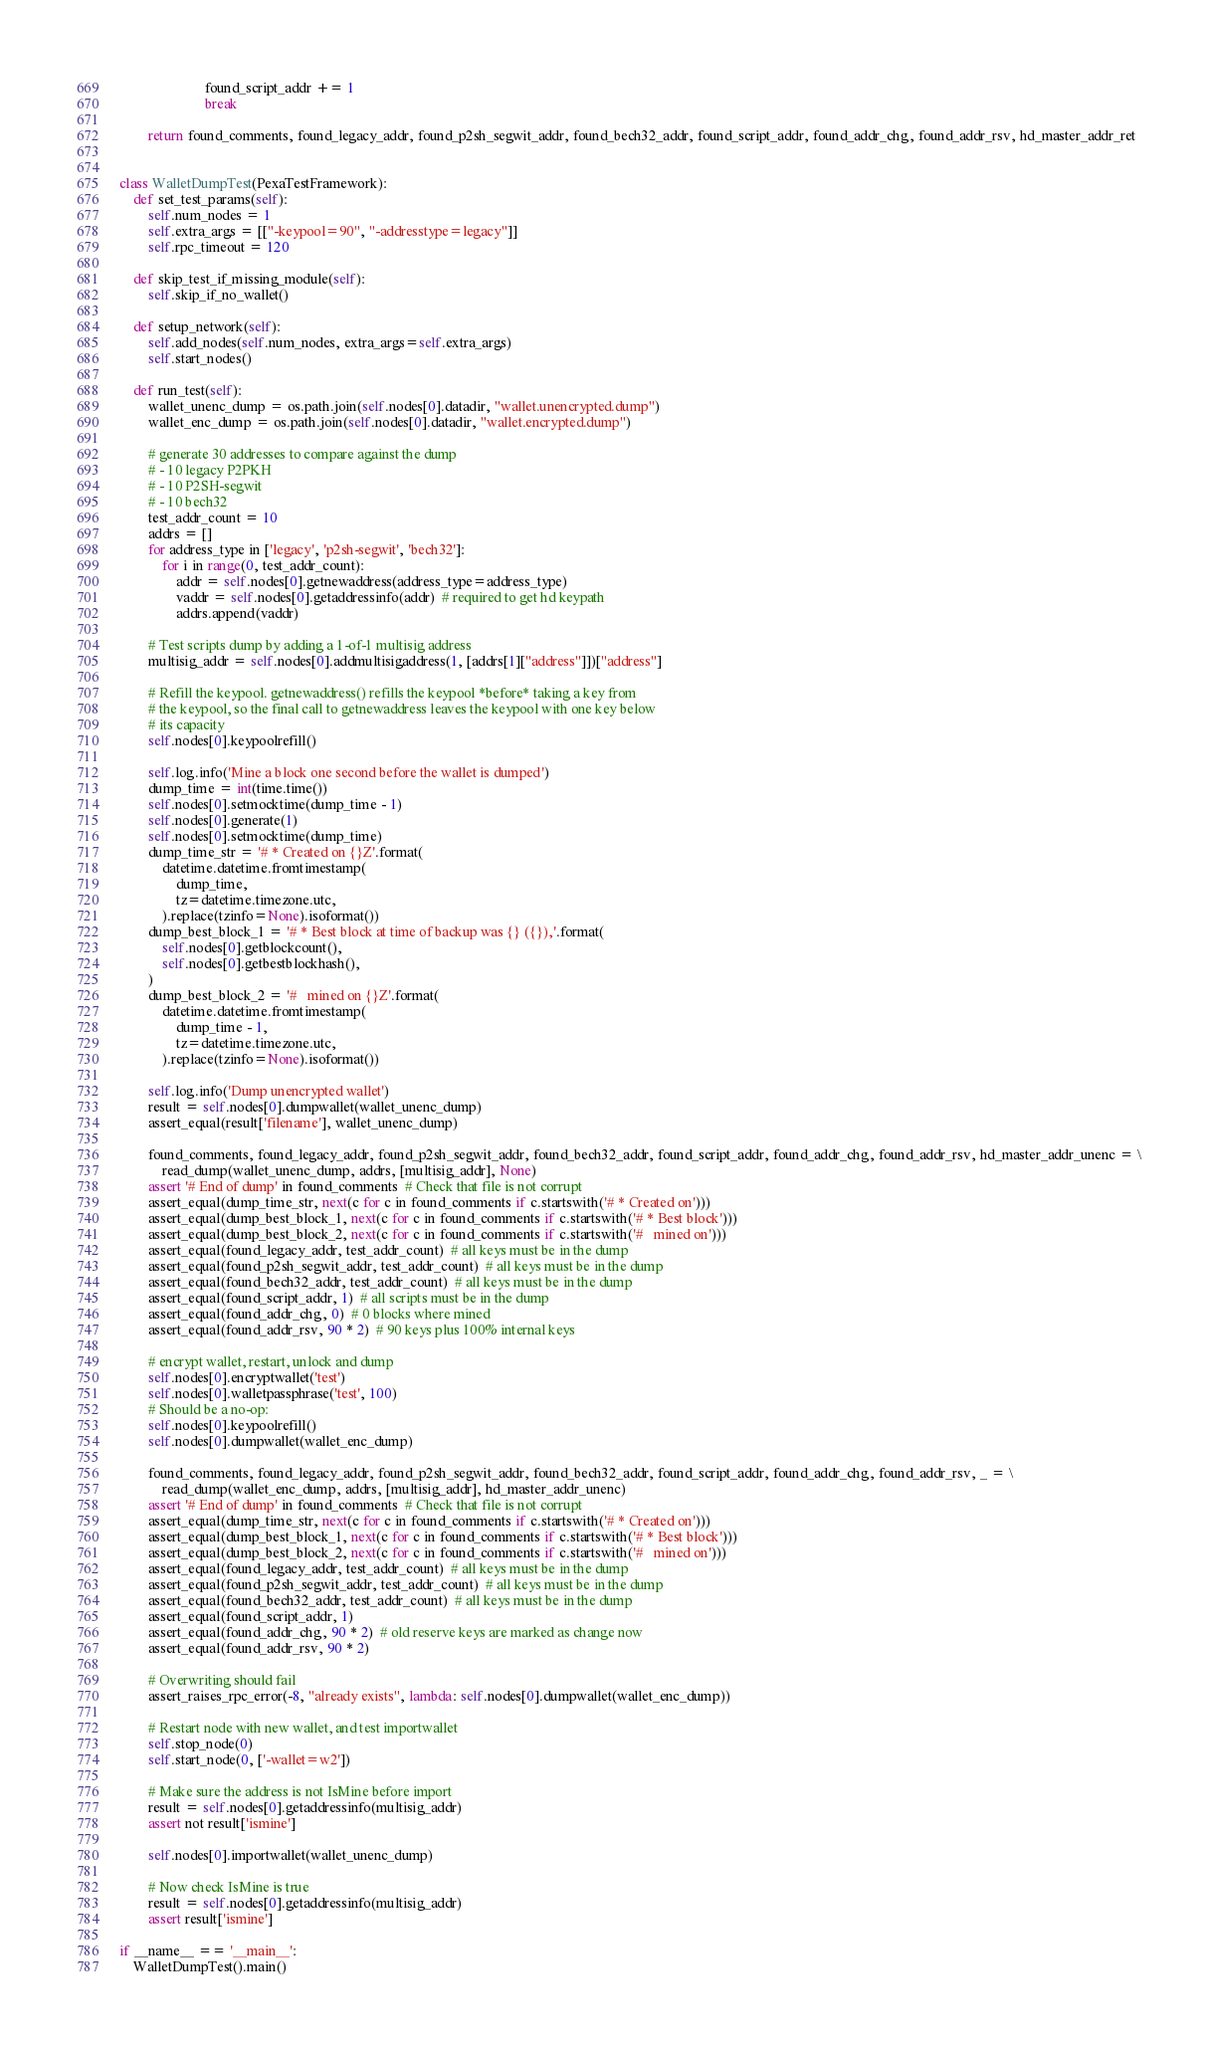<code> <loc_0><loc_0><loc_500><loc_500><_Python_>                        found_script_addr += 1
                        break

        return found_comments, found_legacy_addr, found_p2sh_segwit_addr, found_bech32_addr, found_script_addr, found_addr_chg, found_addr_rsv, hd_master_addr_ret


class WalletDumpTest(PexaTestFramework):
    def set_test_params(self):
        self.num_nodes = 1
        self.extra_args = [["-keypool=90", "-addresstype=legacy"]]
        self.rpc_timeout = 120

    def skip_test_if_missing_module(self):
        self.skip_if_no_wallet()

    def setup_network(self):
        self.add_nodes(self.num_nodes, extra_args=self.extra_args)
        self.start_nodes()

    def run_test(self):
        wallet_unenc_dump = os.path.join(self.nodes[0].datadir, "wallet.unencrypted.dump")
        wallet_enc_dump = os.path.join(self.nodes[0].datadir, "wallet.encrypted.dump")

        # generate 30 addresses to compare against the dump
        # - 10 legacy P2PKH
        # - 10 P2SH-segwit
        # - 10 bech32
        test_addr_count = 10
        addrs = []
        for address_type in ['legacy', 'p2sh-segwit', 'bech32']:
            for i in range(0, test_addr_count):
                addr = self.nodes[0].getnewaddress(address_type=address_type)
                vaddr = self.nodes[0].getaddressinfo(addr)  # required to get hd keypath
                addrs.append(vaddr)

        # Test scripts dump by adding a 1-of-1 multisig address
        multisig_addr = self.nodes[0].addmultisigaddress(1, [addrs[1]["address"]])["address"]

        # Refill the keypool. getnewaddress() refills the keypool *before* taking a key from
        # the keypool, so the final call to getnewaddress leaves the keypool with one key below
        # its capacity
        self.nodes[0].keypoolrefill()

        self.log.info('Mine a block one second before the wallet is dumped')
        dump_time = int(time.time())
        self.nodes[0].setmocktime(dump_time - 1)
        self.nodes[0].generate(1)
        self.nodes[0].setmocktime(dump_time)
        dump_time_str = '# * Created on {}Z'.format(
            datetime.datetime.fromtimestamp(
                dump_time,
                tz=datetime.timezone.utc,
            ).replace(tzinfo=None).isoformat())
        dump_best_block_1 = '# * Best block at time of backup was {} ({}),'.format(
            self.nodes[0].getblockcount(),
            self.nodes[0].getbestblockhash(),
        )
        dump_best_block_2 = '#   mined on {}Z'.format(
            datetime.datetime.fromtimestamp(
                dump_time - 1,
                tz=datetime.timezone.utc,
            ).replace(tzinfo=None).isoformat())

        self.log.info('Dump unencrypted wallet')
        result = self.nodes[0].dumpwallet(wallet_unenc_dump)
        assert_equal(result['filename'], wallet_unenc_dump)

        found_comments, found_legacy_addr, found_p2sh_segwit_addr, found_bech32_addr, found_script_addr, found_addr_chg, found_addr_rsv, hd_master_addr_unenc = \
            read_dump(wallet_unenc_dump, addrs, [multisig_addr], None)
        assert '# End of dump' in found_comments  # Check that file is not corrupt
        assert_equal(dump_time_str, next(c for c in found_comments if c.startswith('# * Created on')))
        assert_equal(dump_best_block_1, next(c for c in found_comments if c.startswith('# * Best block')))
        assert_equal(dump_best_block_2, next(c for c in found_comments if c.startswith('#   mined on')))
        assert_equal(found_legacy_addr, test_addr_count)  # all keys must be in the dump
        assert_equal(found_p2sh_segwit_addr, test_addr_count)  # all keys must be in the dump
        assert_equal(found_bech32_addr, test_addr_count)  # all keys must be in the dump
        assert_equal(found_script_addr, 1)  # all scripts must be in the dump
        assert_equal(found_addr_chg, 0)  # 0 blocks where mined
        assert_equal(found_addr_rsv, 90 * 2)  # 90 keys plus 100% internal keys

        # encrypt wallet, restart, unlock and dump
        self.nodes[0].encryptwallet('test')
        self.nodes[0].walletpassphrase('test', 100)
        # Should be a no-op:
        self.nodes[0].keypoolrefill()
        self.nodes[0].dumpwallet(wallet_enc_dump)

        found_comments, found_legacy_addr, found_p2sh_segwit_addr, found_bech32_addr, found_script_addr, found_addr_chg, found_addr_rsv, _ = \
            read_dump(wallet_enc_dump, addrs, [multisig_addr], hd_master_addr_unenc)
        assert '# End of dump' in found_comments  # Check that file is not corrupt
        assert_equal(dump_time_str, next(c for c in found_comments if c.startswith('# * Created on')))
        assert_equal(dump_best_block_1, next(c for c in found_comments if c.startswith('# * Best block')))
        assert_equal(dump_best_block_2, next(c for c in found_comments if c.startswith('#   mined on')))
        assert_equal(found_legacy_addr, test_addr_count)  # all keys must be in the dump
        assert_equal(found_p2sh_segwit_addr, test_addr_count)  # all keys must be in the dump
        assert_equal(found_bech32_addr, test_addr_count)  # all keys must be in the dump
        assert_equal(found_script_addr, 1)
        assert_equal(found_addr_chg, 90 * 2)  # old reserve keys are marked as change now
        assert_equal(found_addr_rsv, 90 * 2)

        # Overwriting should fail
        assert_raises_rpc_error(-8, "already exists", lambda: self.nodes[0].dumpwallet(wallet_enc_dump))

        # Restart node with new wallet, and test importwallet
        self.stop_node(0)
        self.start_node(0, ['-wallet=w2'])

        # Make sure the address is not IsMine before import
        result = self.nodes[0].getaddressinfo(multisig_addr)
        assert not result['ismine']

        self.nodes[0].importwallet(wallet_unenc_dump)

        # Now check IsMine is true
        result = self.nodes[0].getaddressinfo(multisig_addr)
        assert result['ismine']

if __name__ == '__main__':
    WalletDumpTest().main()
</code> 